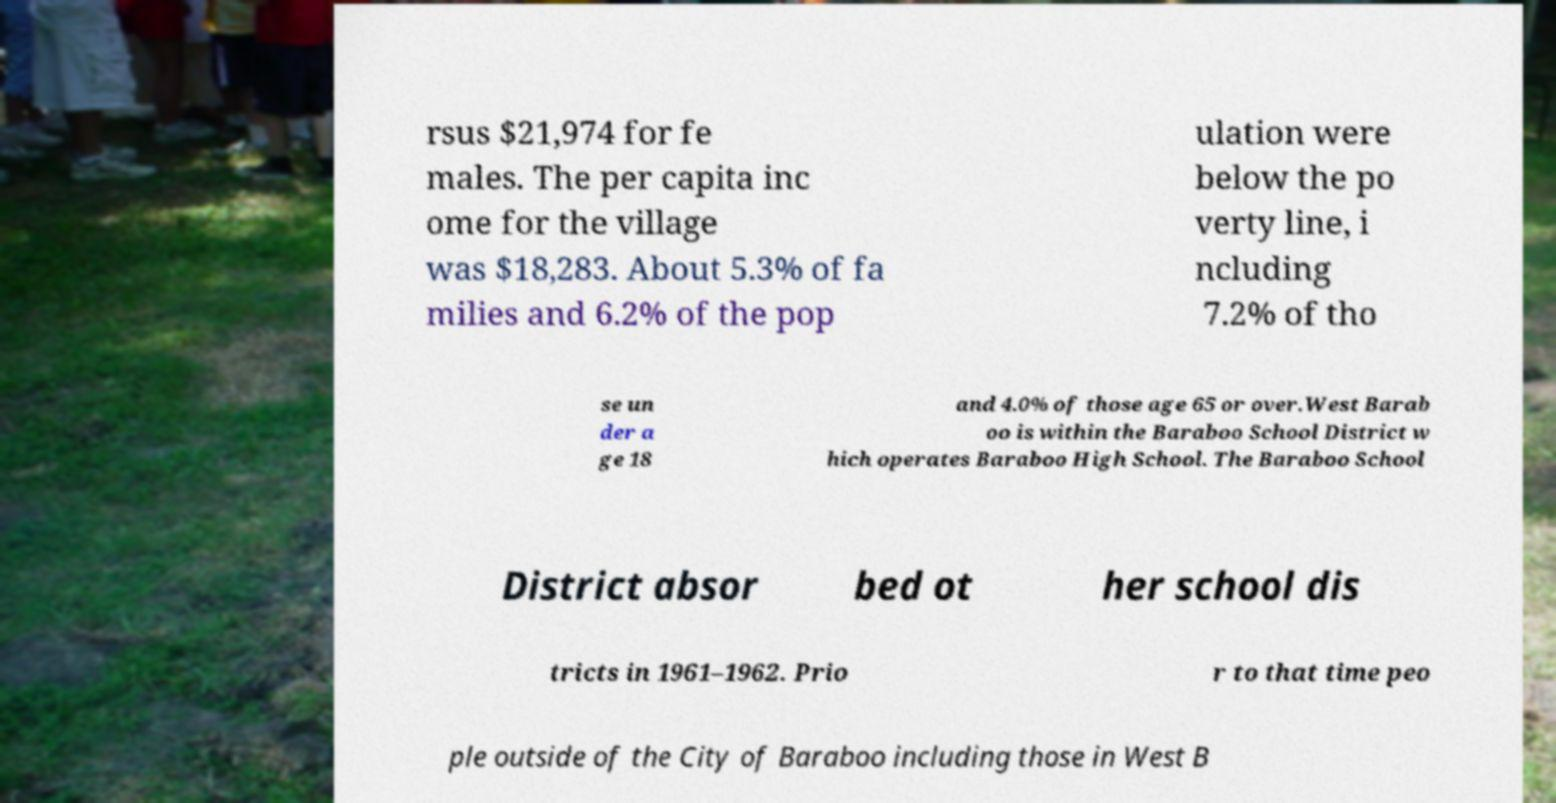What messages or text are displayed in this image? I need them in a readable, typed format. rsus $21,974 for fe males. The per capita inc ome for the village was $18,283. About 5.3% of fa milies and 6.2% of the pop ulation were below the po verty line, i ncluding 7.2% of tho se un der a ge 18 and 4.0% of those age 65 or over.West Barab oo is within the Baraboo School District w hich operates Baraboo High School. The Baraboo School District absor bed ot her school dis tricts in 1961–1962. Prio r to that time peo ple outside of the City of Baraboo including those in West B 